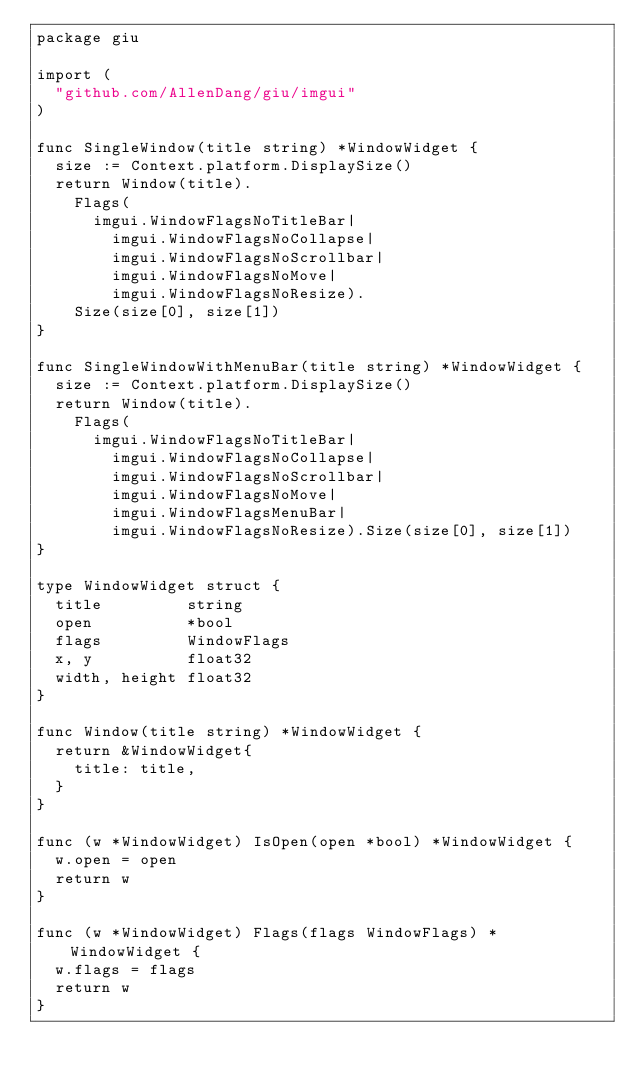Convert code to text. <code><loc_0><loc_0><loc_500><loc_500><_Go_>package giu

import (
	"github.com/AllenDang/giu/imgui"
)

func SingleWindow(title string) *WindowWidget {
	size := Context.platform.DisplaySize()
	return Window(title).
		Flags(
			imgui.WindowFlagsNoTitleBar|
				imgui.WindowFlagsNoCollapse|
				imgui.WindowFlagsNoScrollbar|
				imgui.WindowFlagsNoMove|
				imgui.WindowFlagsNoResize).
		Size(size[0], size[1])
}

func SingleWindowWithMenuBar(title string) *WindowWidget {
	size := Context.platform.DisplaySize()
	return Window(title).
		Flags(
			imgui.WindowFlagsNoTitleBar|
				imgui.WindowFlagsNoCollapse|
				imgui.WindowFlagsNoScrollbar|
				imgui.WindowFlagsNoMove|
				imgui.WindowFlagsMenuBar|
				imgui.WindowFlagsNoResize).Size(size[0], size[1])
}

type WindowWidget struct {
	title         string
	open          *bool
	flags         WindowFlags
	x, y          float32
	width, height float32
}

func Window(title string) *WindowWidget {
	return &WindowWidget{
		title: title,
	}
}

func (w *WindowWidget) IsOpen(open *bool) *WindowWidget {
	w.open = open
	return w
}

func (w *WindowWidget) Flags(flags WindowFlags) *WindowWidget {
	w.flags = flags
	return w
}
</code> 